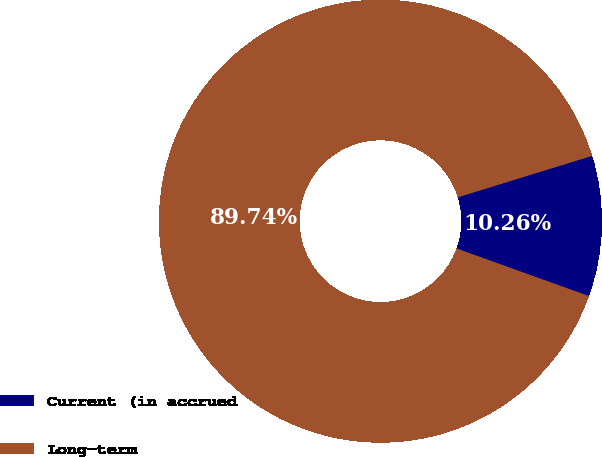<chart> <loc_0><loc_0><loc_500><loc_500><pie_chart><fcel>Current (in accrued<fcel>Long-term<nl><fcel>10.26%<fcel>89.74%<nl></chart> 